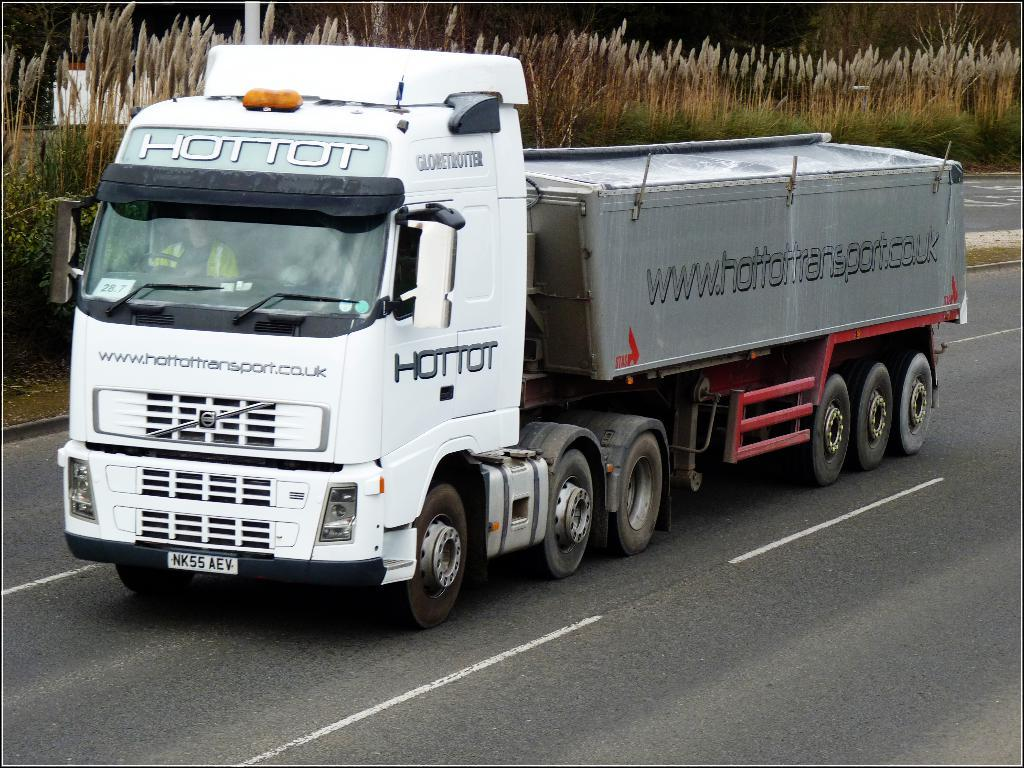What is the main subject in the foreground of the image? There is a truck in the foreground of the image. Where is the truck located? The truck is on the road. What can be seen in the background of the image? There are crops and trees in the background of the image. What type of structure does the truck's father own in the image? There is no information about the truck's father or any structures in the image. 